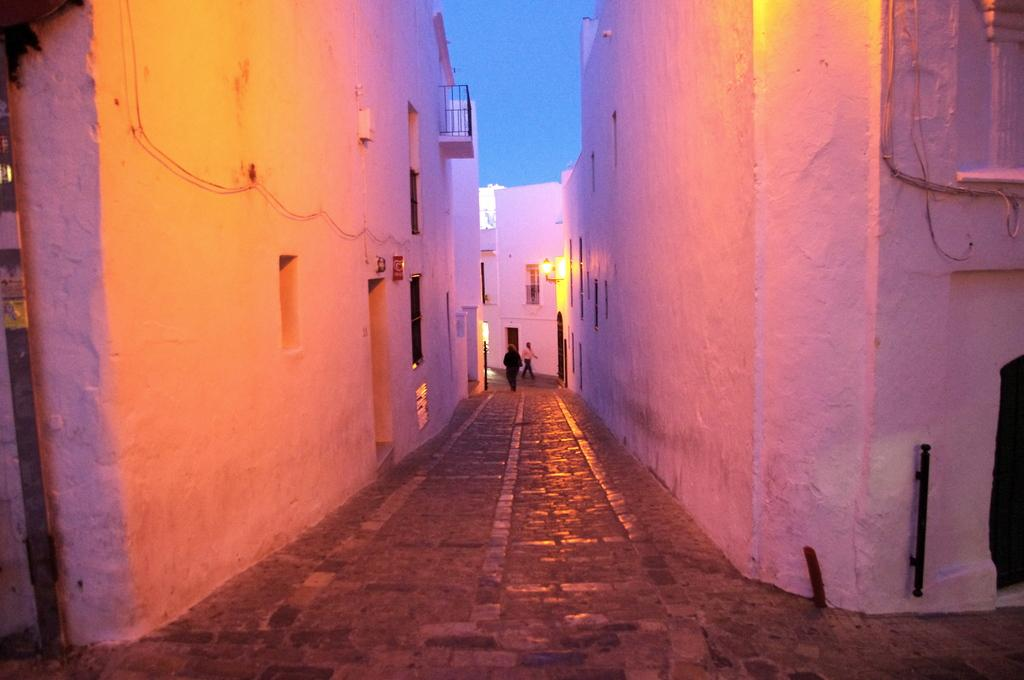What can be seen in the foreground of the image? There is a path in the foreground of the image. What surrounds the path? There are walls on either side of the path. What features can be seen on the walls? There are windows and doors on the walls. What is visible in the background of the image? In the background, there is a light, and two people are walking. The sky is also visible. What type of support can be seen holding up the building in the image? There is no building present in the image, so there is no support to hold it up. 